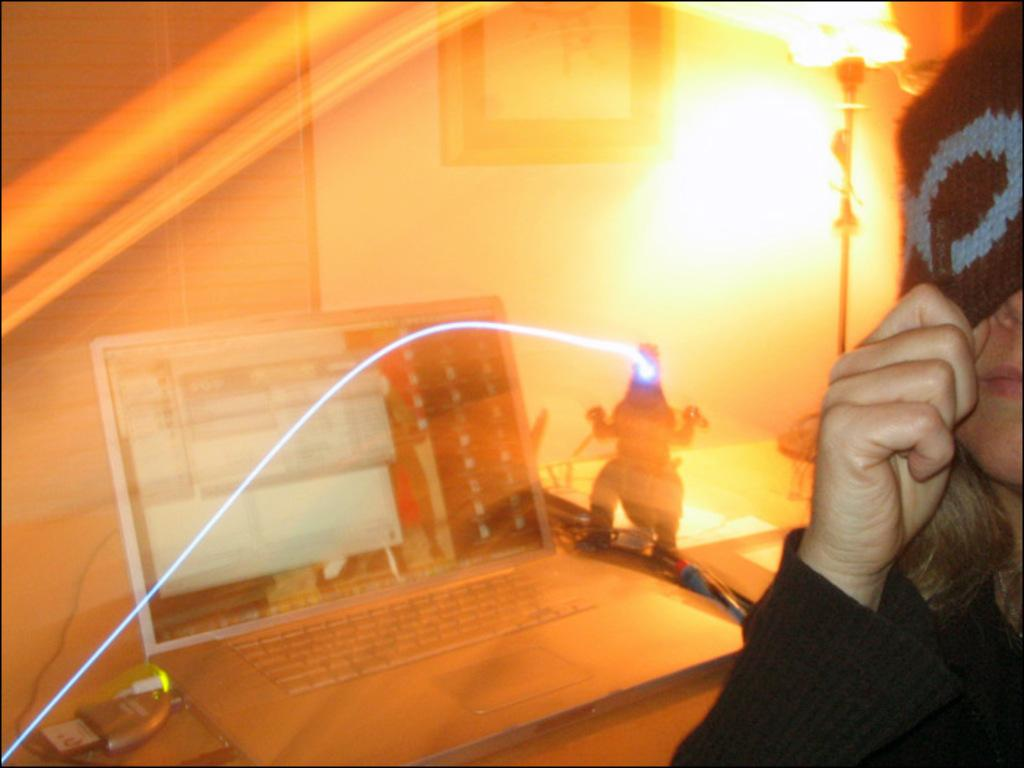Who or what is present in the image? There is a person in the image. What electronic device can be seen in the image? There is a laptop in the image. What type of plaything is visible in the image? There is a toy in the image. What other objects are on the table in the image? There are other objects on a table in the image. What can be seen on the wall in the image? There is a wall with a photo on it in the image. What type of engine can be seen in the image? There is no engine present in the image. What color are the person's lips in the image? The provided facts do not mention the color of the person's lips, so we cannot determine that information from the image. 